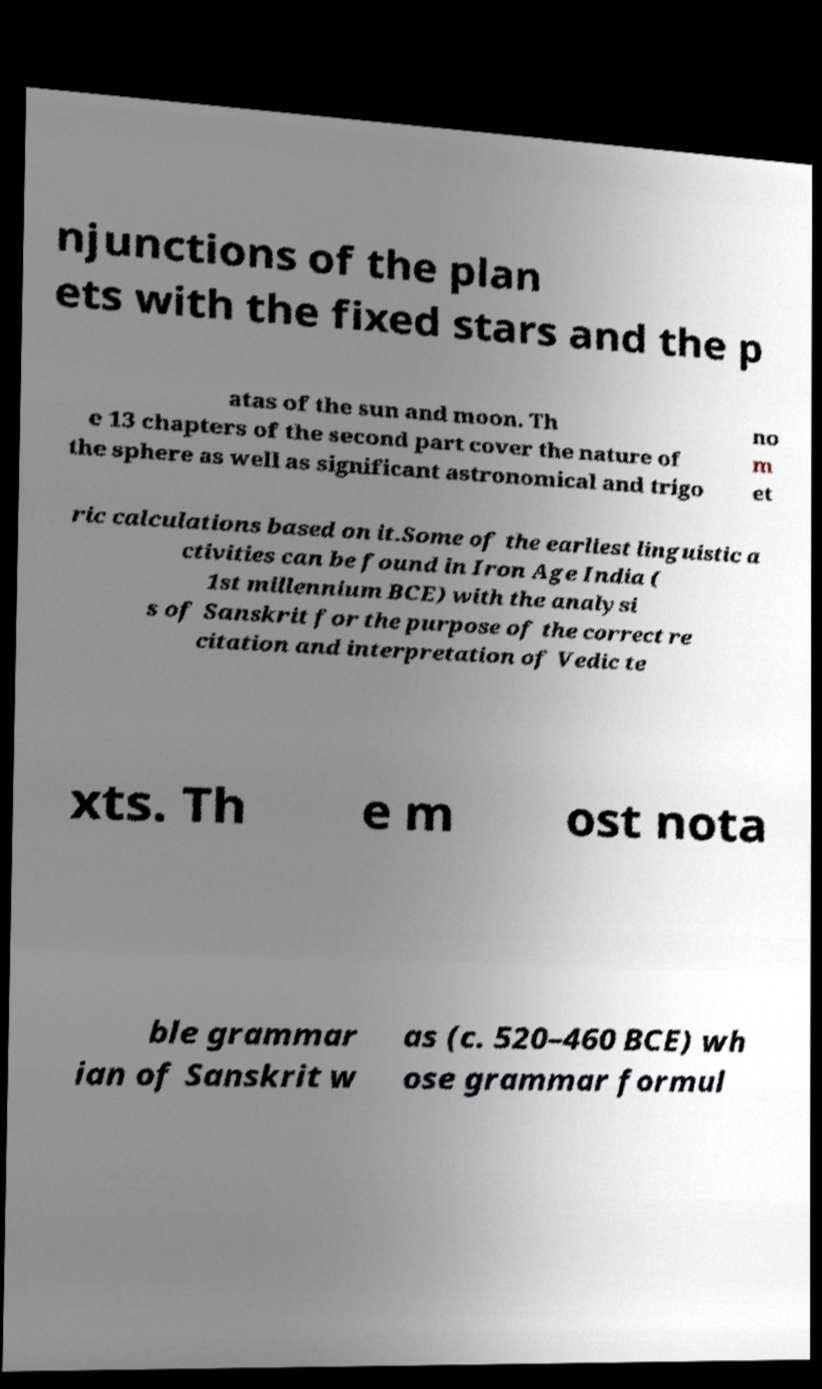Can you read and provide the text displayed in the image?This photo seems to have some interesting text. Can you extract and type it out for me? njunctions of the plan ets with the fixed stars and the p atas of the sun and moon. Th e 13 chapters of the second part cover the nature of the sphere as well as significant astronomical and trigo no m et ric calculations based on it.Some of the earliest linguistic a ctivities can be found in Iron Age India ( 1st millennium BCE) with the analysi s of Sanskrit for the purpose of the correct re citation and interpretation of Vedic te xts. Th e m ost nota ble grammar ian of Sanskrit w as (c. 520–460 BCE) wh ose grammar formul 